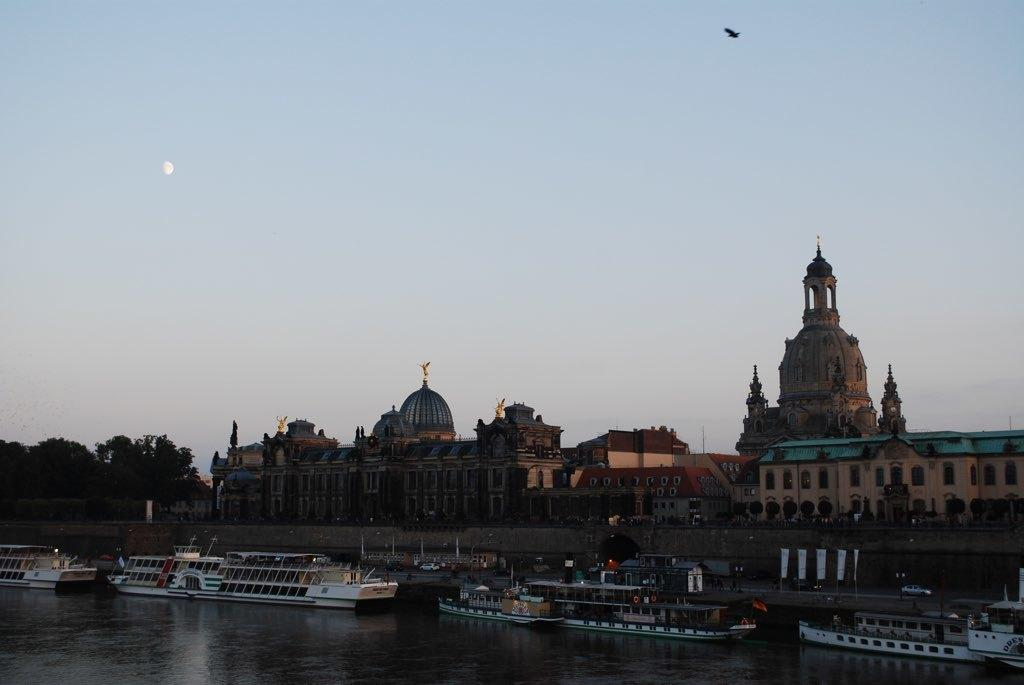What type of structures can be seen in the image? There are buildings in the image. What other natural elements are present in the image? There are trees and water visible in the image. What is floating on the water in the image? Boats are visible on the water. What part of the natural environment is visible in the image? The sky is visible in the background of the image. Can any living creatures be seen in the sky? Yes, a bird is present in the sky. What type of toy can be seen on the roof of the building in the image? There is no toy present on the roof of the building in the image. What force is causing the bird to fly in the image? The image does not provide information about the force causing the bird to fly; it simply shows the bird in the sky. 